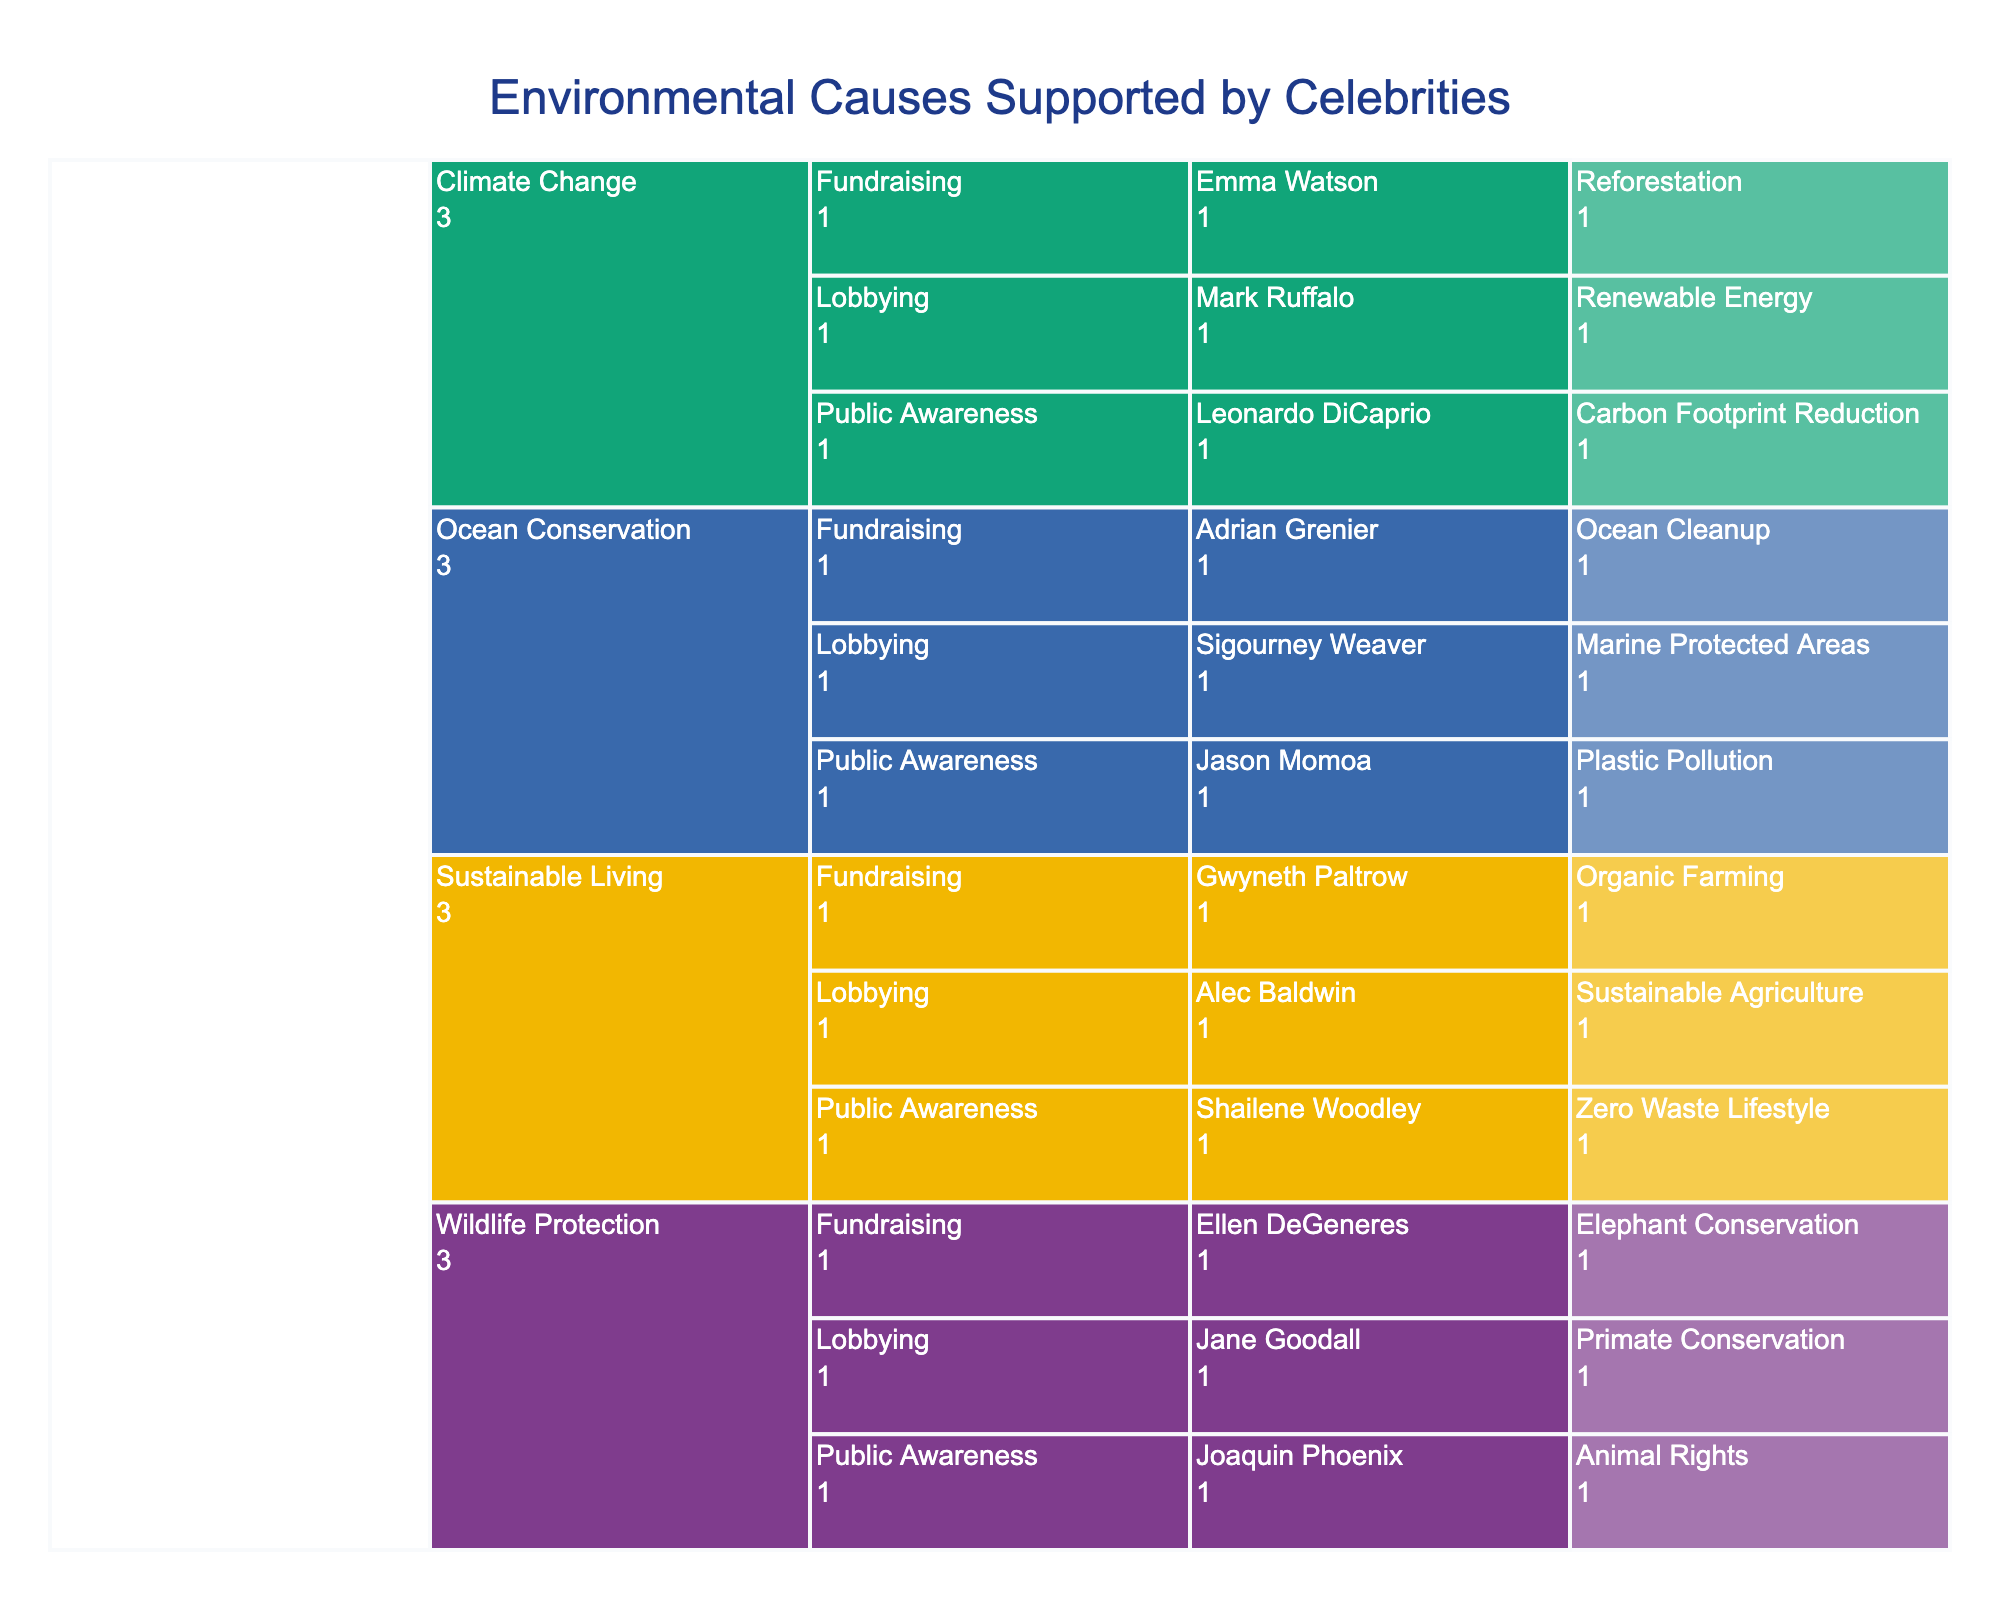What is the title of the figure? The title can be found at the top of the figure. It summarizes what the entire chart is about.
Answer: Environmental Causes Supported by Celebrities How many celebrities are advocating for Climate Change? Look at each branch under the Climate Change category and count the number of celebrities listed.
Answer: 3 Who is advocating for Marine Protected Areas? Find the Ocean Conservation category, locate the Advocacy Type labeled Lobbying, and identify the celebrity associated with Marine Protected Areas.
Answer: Sigourney Weaver Which environmental issue has the most celebrities supporting it? Compare the number of celebrities in each major issue category (Climate Change, Ocean Conservation, Wildlife Protection, Sustainable Living) by counting the branches under each category.
Answer: Sustainable Living Which Advocacy Type under Wildlife Protection has the most celebrities? Within the Wildlife Protection category, observe the subdivisions and count the number of celebrities in each Advocacy Type (Public Awareness, Lobbying, Fundraising).
Answer: It's a tie (each has 1) Who is contributing to Fundraising efforts for Reforestation? Navigate to the Climate Change category, select the Fundraising Advocacy Type, and identify the celebrity associated with Reforestation.
Answer: Emma Watson Compare the number of celebrities involved in Public Awareness efforts for Climate Change versus Ocean Conservation. Which has more? Count the number of celebrities under Public Awareness for both Climate Change and Ocean Conservation categories and compare these counts.
Answer: Climate Change Which celebrity is involved in Organic Farming? Look under the Sustainable Living category, identify the Fundraising Advocacy Type, and find the associated celebrity.
Answer: Gwyneth Paltrow What are the specific causes advocated for under Ocean Conservation by celebrities? In the Ocean Conservation category, list out the causes mentioned for each celebrity under different Advocacy Types.
Answer: Plastic Pollution, Marine Protected Areas, Ocean Cleanup How many total Advocacy Types are represented in the figure? Count each unique Advocacy Type listed under the different environmental issues.
Answer: 3 